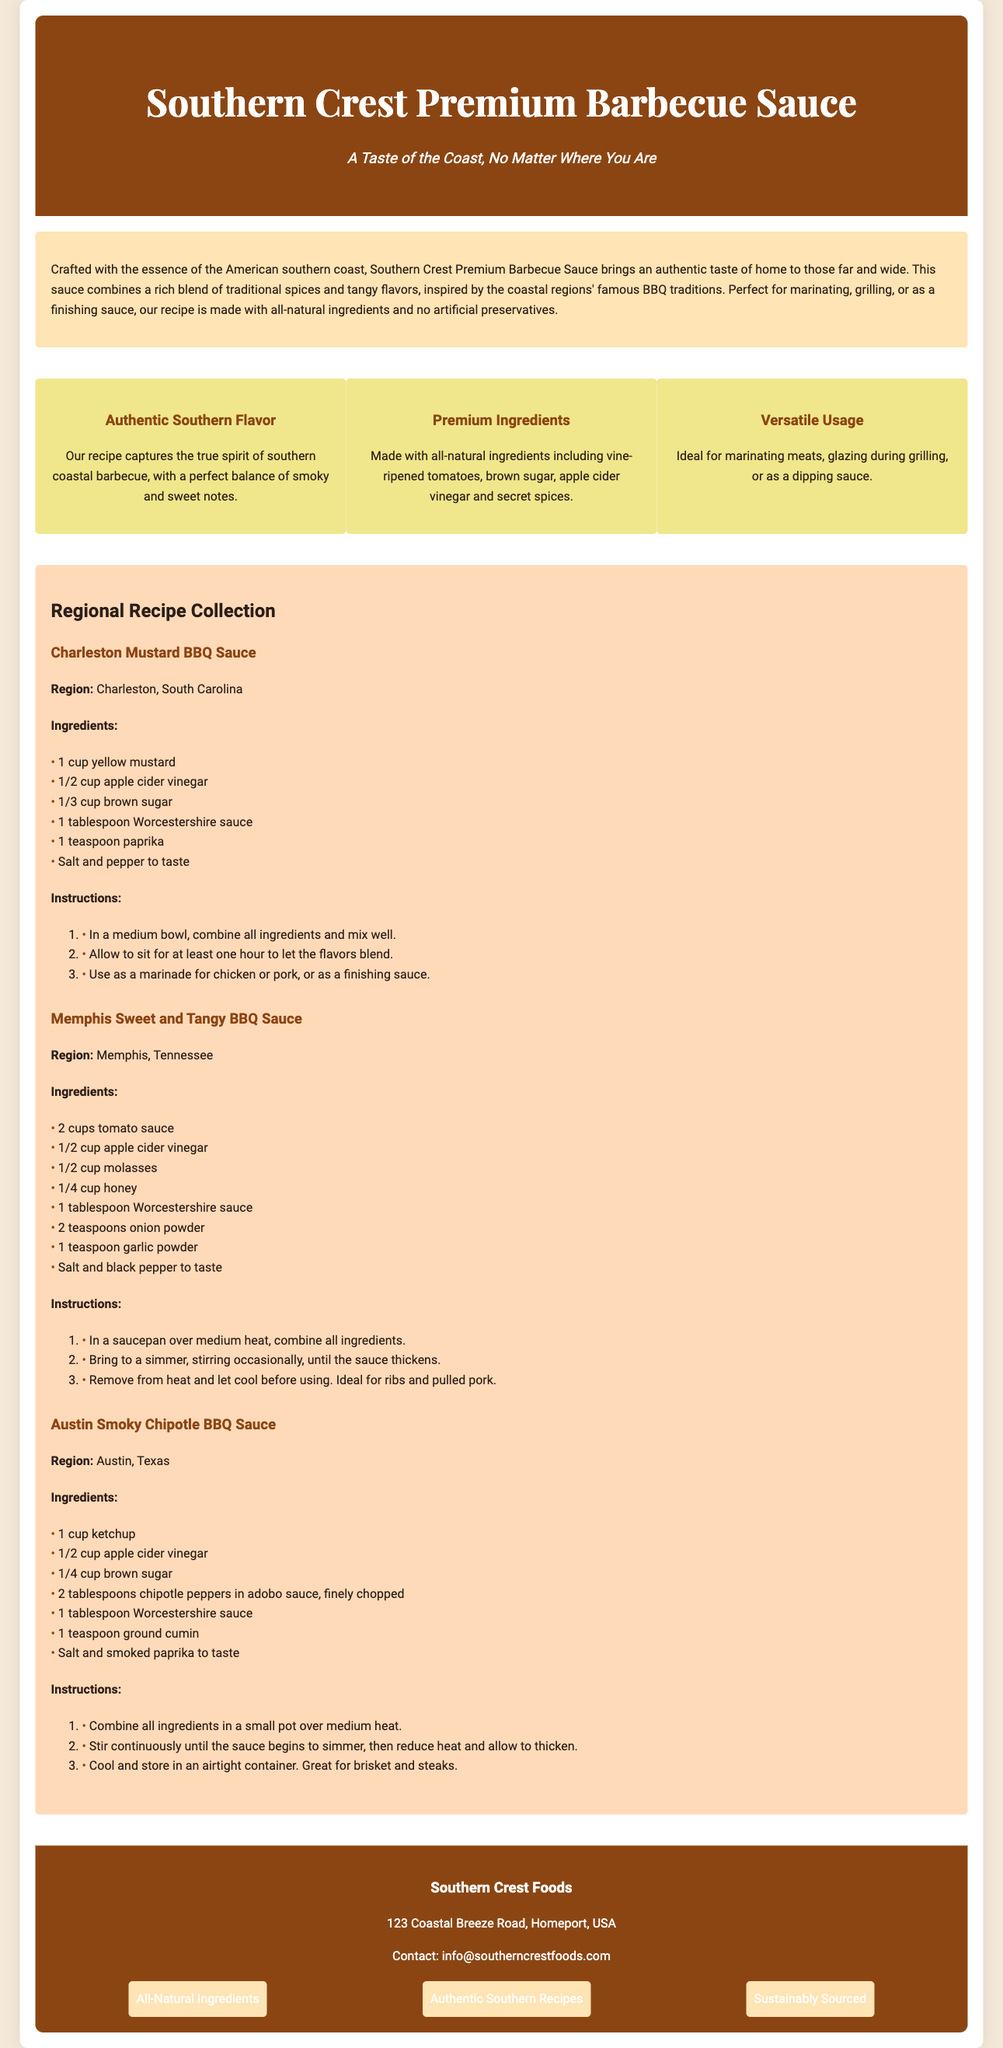What is the name of the barbecue sauce? The name of the barbecue sauce is stated in the header of the document.
Answer: Southern Crest Premium Barbecue Sauce What is the product tagline? The tagline is positioned below the product name, providing a catchy phrase.
Answer: A Taste of the Coast, No Matter Where You Are How many regional recipes are included? The number of regional recipes can be determined by counting the sections under the recipe collection title.
Answer: Three What is the main ingredient in Charleston Mustard BBQ Sauce? The main ingredient can be identified from the ingredient list provided for the Charleston recipe.
Answer: Yellow mustard Which region is the Austin Smoky Chipotle BBQ Sauce from? The region is specified in the recipe section header for that particular sauce.
Answer: Austin, Texas What is the primary sweetening agent in Memphis Sweet and Tangy BBQ Sauce? The sweetening agent is mentioned in the ingredients list in the Memphis recipe.
Answer: Molasses What ingredient is common in all the recipes? Common ingredients are listed in each recipe, and can be seen by cross-referencing them.
Answer: Apple cider vinegar What type of ingredients does Southern Crest use? The type of ingredients is mentioned in the highlights and final brand values sections.
Answer: All-natural ingredients What contact information is provided for Southern Crest Foods? The contact information can be found in the footer section of the document.
Answer: info@southerncrestfoods.com 